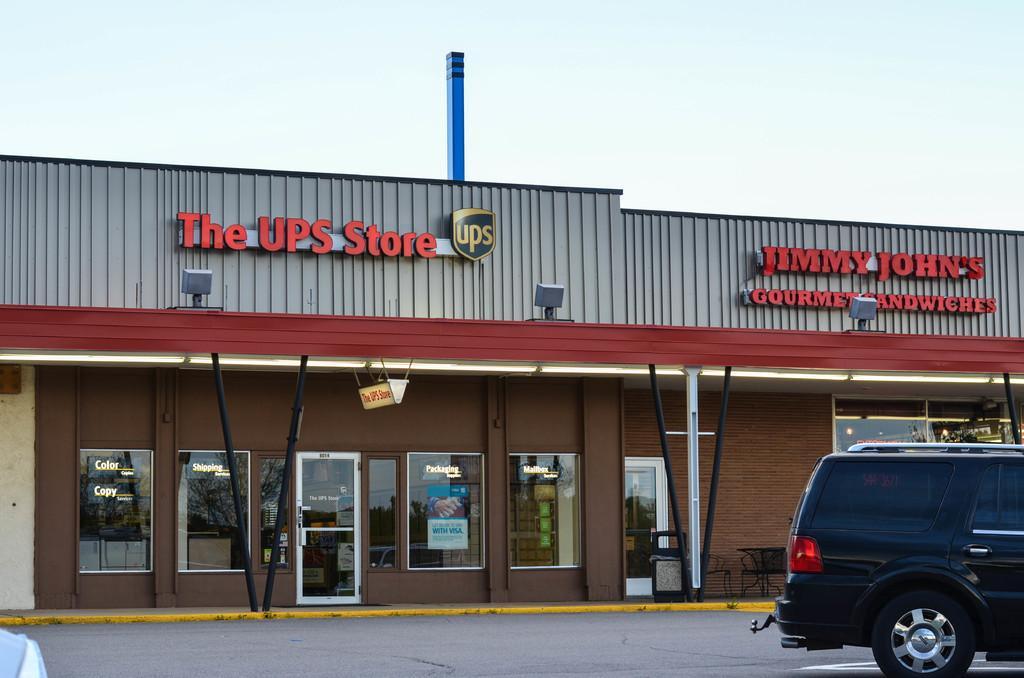In one or two sentences, can you explain what this image depicts? At the top there is a sky. In this picture we can see stores. On the right side of the picture there is a vehicle. 